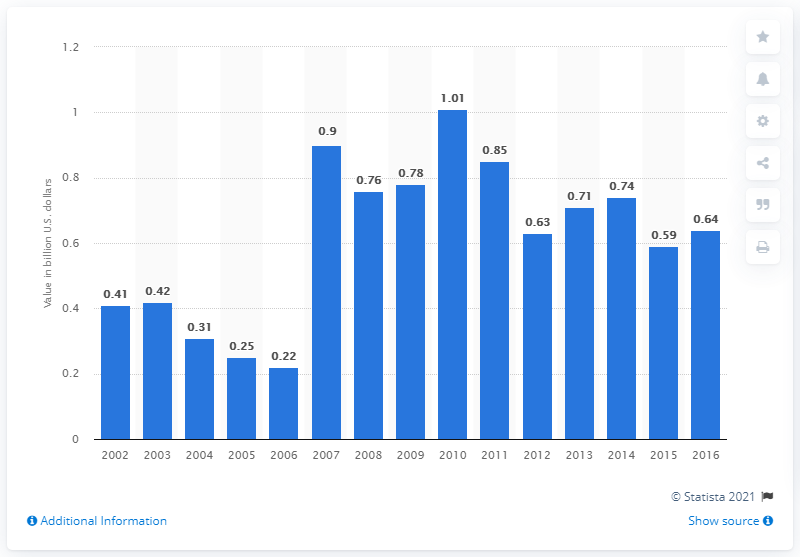Highlight a few significant elements in this photo. The value of tobacco shipments in the United States in 2016 was approximately 0.64 billion dollars. 